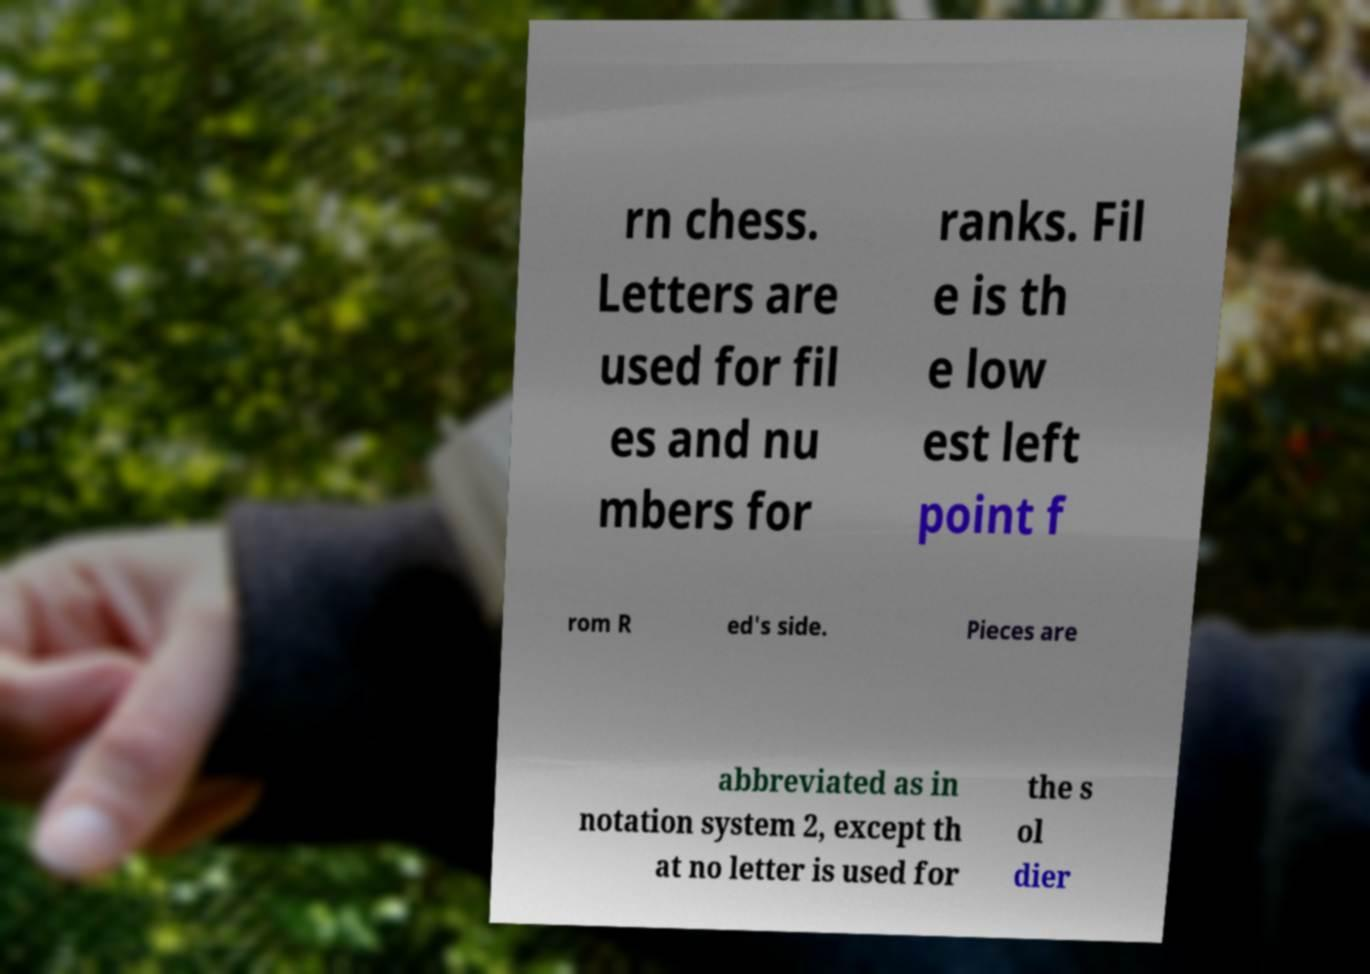Please read and relay the text visible in this image. What does it say? rn chess. Letters are used for fil es and nu mbers for ranks. Fil e is th e low est left point f rom R ed's side. Pieces are abbreviated as in notation system 2, except th at no letter is used for the s ol dier 